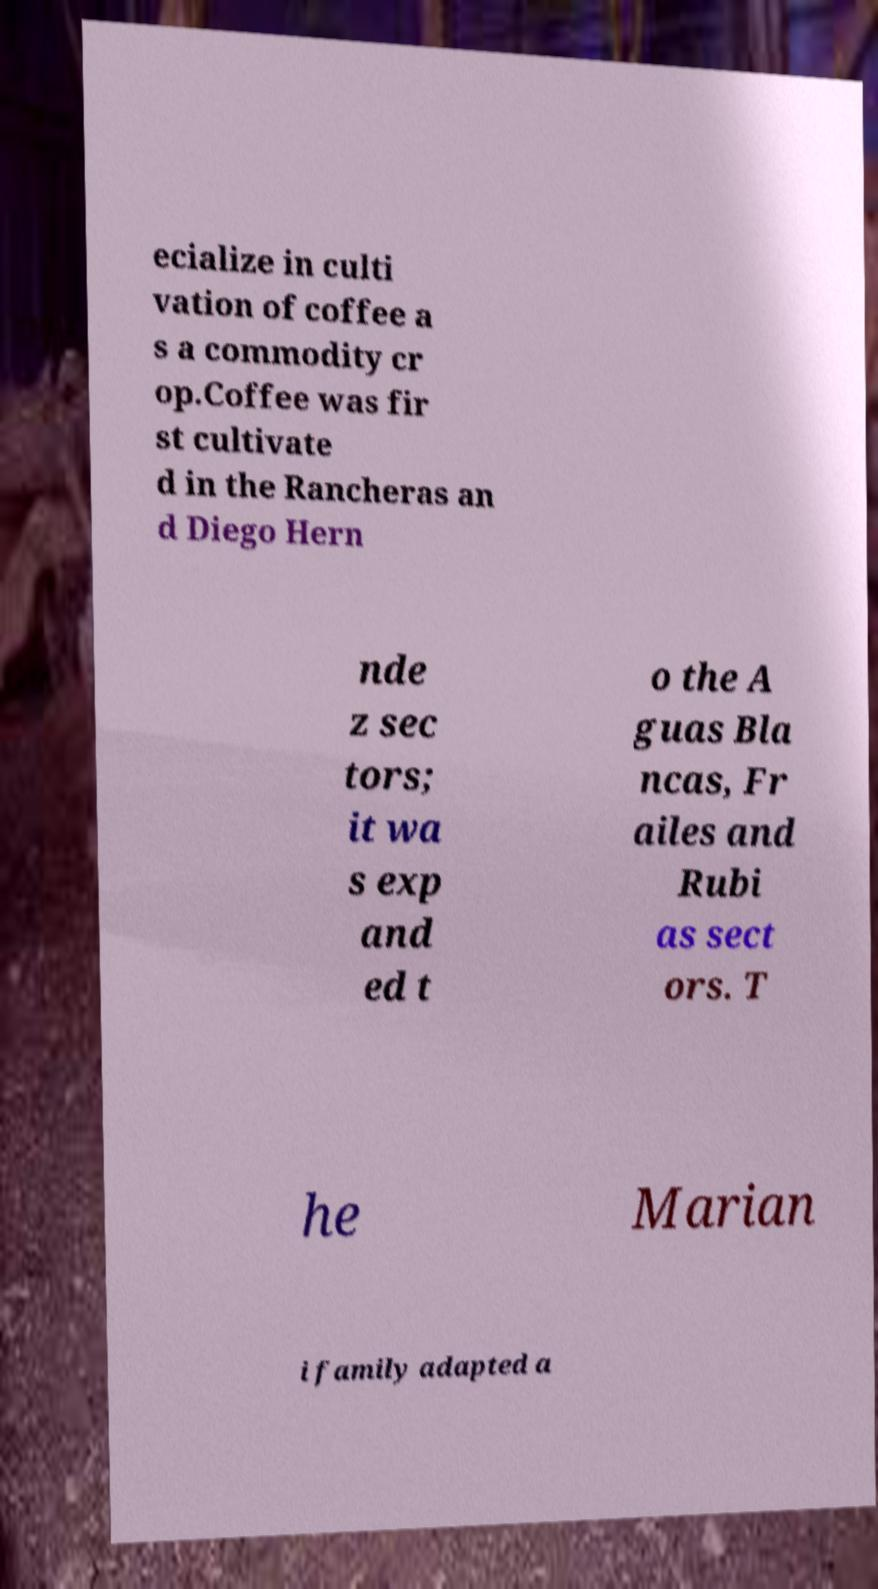For documentation purposes, I need the text within this image transcribed. Could you provide that? ecialize in culti vation of coffee a s a commodity cr op.Coffee was fir st cultivate d in the Rancheras an d Diego Hern nde z sec tors; it wa s exp and ed t o the A guas Bla ncas, Fr ailes and Rubi as sect ors. T he Marian i family adapted a 